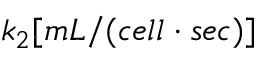<formula> <loc_0><loc_0><loc_500><loc_500>k _ { 2 } [ m L / ( c e l l \cdot s e c ) ]</formula> 